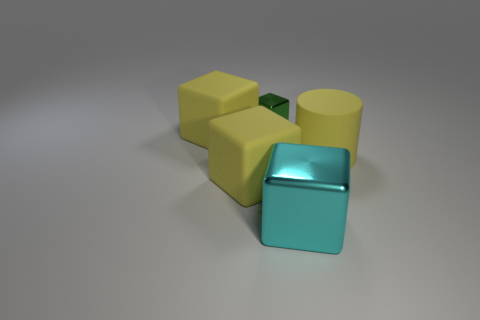Can you tell the approximate time of day it is in this image? The image does not provide any context that would indicate time of day, as it is a studio setup with controlled lighting, typically used to eliminate external variables such as time of day. Given the controlled lighting, how would you describe the mood or atmosphere of the image? The image has a neutral, calm atmosphere due to the even and soft lighting, which minimizes harsh shadows and creates a balanced scene. The muted colors of the objects contribute to a subdued and professional vibe. 